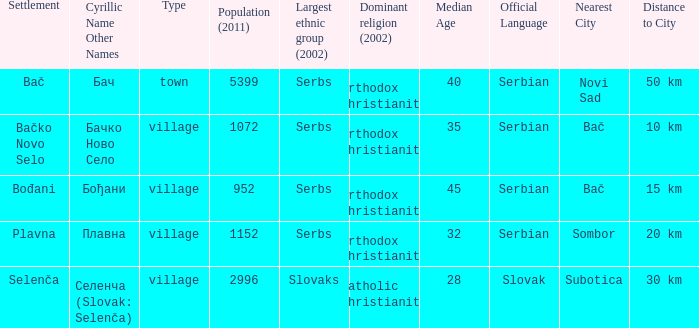What is the second way of writting плавна. Plavna. 